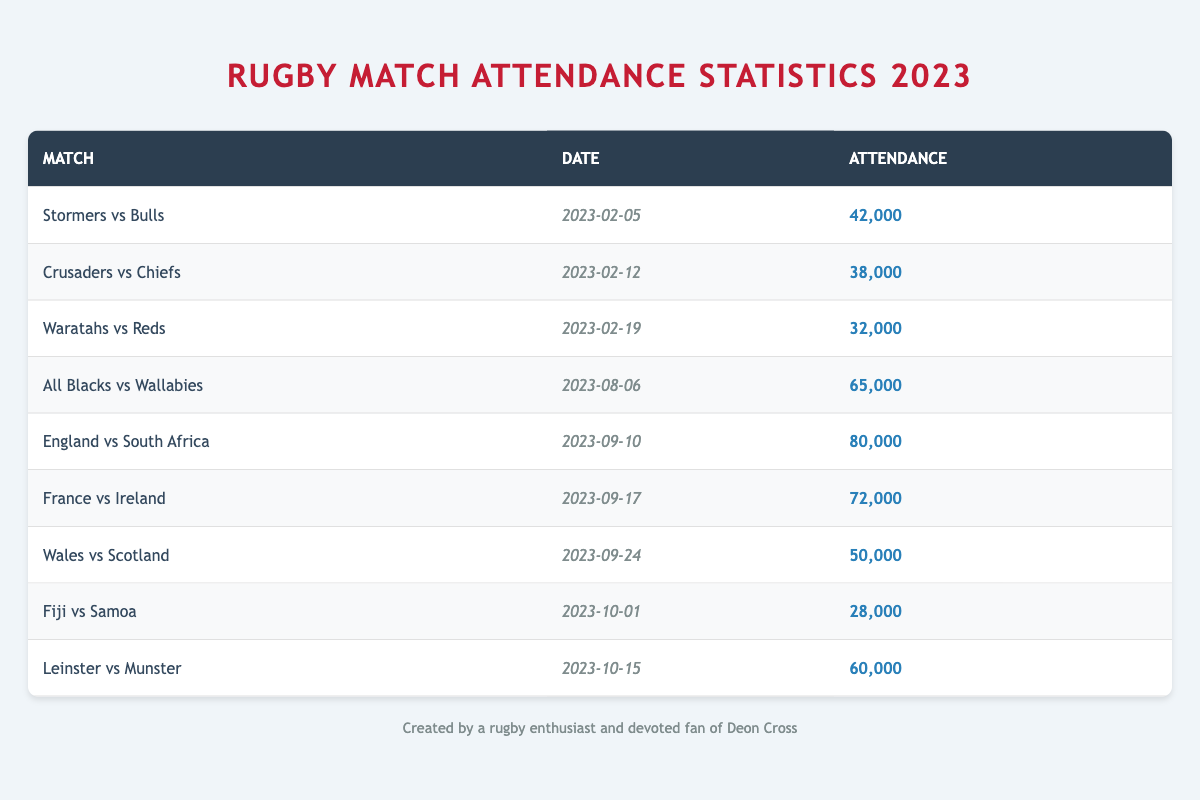What is the highest attendance recorded in a match? The highest attendance is found by inspecting the "attendance" column for the largest value. In this case, the match "England vs South Africa" has an attendance of 80,000, which is the highest among all listed matches.
Answer: 80,000 Which match had an attendance of 60,000? To find the match with an attendance of 60,000, we look through the attendance column. The match "Leinster vs Munster" is listed with an attendance of 60,000.
Answer: Leinster vs Munster What is the average attendance of matches held in September? There are three matches in September with attendances of 80,000, 72,000, and 50,000. First, we sum these values: 80,000 + 72,000 + 50,000 = 202,000. Then, we divide by the number of matches (3): 202,000 / 3 = 67,333.33. Thus, the average attendance for September matches is approximately 67,333.
Answer: 67,333 Is the attendance for "Crusaders vs Chiefs" greater than 40,000? By checking the table, the attendance for "Crusaders vs Chiefs" is 38,000, which is less than 40,000. Therefore, the statement is false.
Answer: No How many matches had attendances above 50,000? We analyze the attendance numbers and count the matches with attendance greater than 50,000: "All Blacks vs Wallabies" (65,000), "England vs South Africa" (80,000), "France vs Ireland" (72,000), and "Wales vs Scotland" (50,000 is not included as it is not above 50,000). This gives us a total of three matches with attendance above 50,000.
Answer: 3 